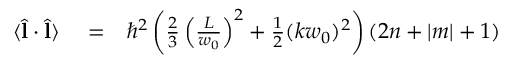<formula> <loc_0><loc_0><loc_500><loc_500>\begin{array} { r l r } { \langle \hat { l } \cdot \hat { l } \rangle } & = } & { \hbar { ^ } { 2 } \left ( \frac { 2 } { 3 } \left ( \frac { L } { w _ { 0 } } \right ) ^ { 2 } + \frac { 1 } { 2 } ( k w _ { 0 } ) ^ { 2 } \right ) ( 2 n + | m | + 1 ) } \end{array}</formula> 